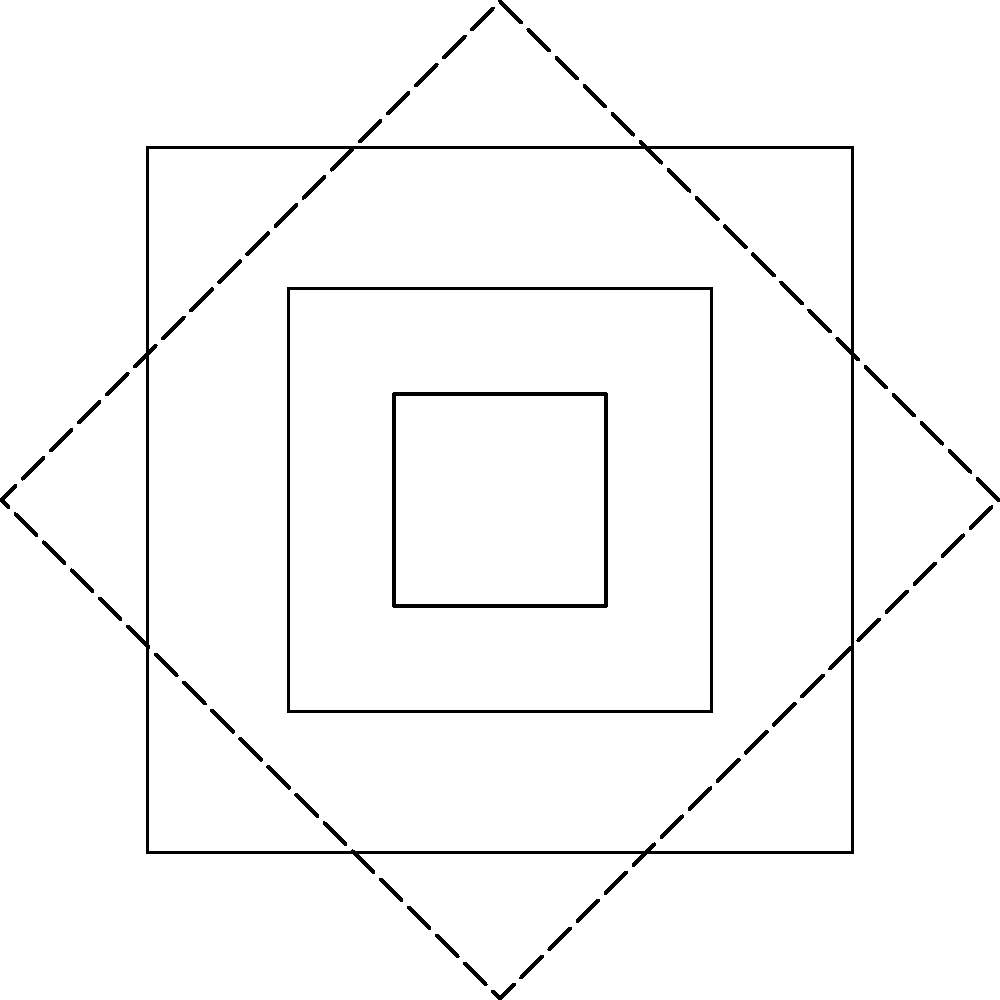The Adinkra symbol "Nyame Nti" (meaning "By God's grace") is shown above. If we consider the rotational symmetries of this symbol as elements of a cyclic group, what is the order of this group, and how does it relate to the concept of cultural preservation in Ghanaian symbolism? To determine the order of the cyclic group representing the rotational symmetries of the Nyame Nti symbol, we need to follow these steps:

1. Observe the symbol's symmetry: The Nyame Nti symbol has a square shape with internal square designs.

2. Identify rotational symmetries: The symbol remains unchanged when rotated by 90°, 180°, 270°, and 360° (full rotation).

3. Count distinct rotations: There are 4 distinct rotations (including the identity rotation of 0° or 360°).

4. Determine the group order: The order of the cyclic group is equal to the number of distinct rotations, which is 4.

5. Relate to cultural preservation:
   a) The cyclic group $C_4$ represents the mathematical structure of the symbol's symmetry.
   b) This structure reflects the importance of balance and harmony in Ghanaian culture.
   c) Understanding the mathematical properties helps in accurately preserving and reproducing the symbol.
   d) The four-fold symmetry may relate to cultural concepts such as the four cardinal directions or four stages of life.

6. Anthropological significance:
   a) Preserving the exact symmetry ensures the symbol's cultural meaning is maintained.
   b) The mathematical analysis provides a tool for authenticating traditional designs.
   c) It demonstrates the sophistication of traditional Ghanaian geometric knowledge.

By recognizing the $C_4$ group structure in the Nyame Nti symbol, we can better appreciate and preserve the cultural significance and mathematical complexity inherent in Adinkra symbols.
Answer: Order 4 ($C_4$); preserves geometric and cultural integrity 